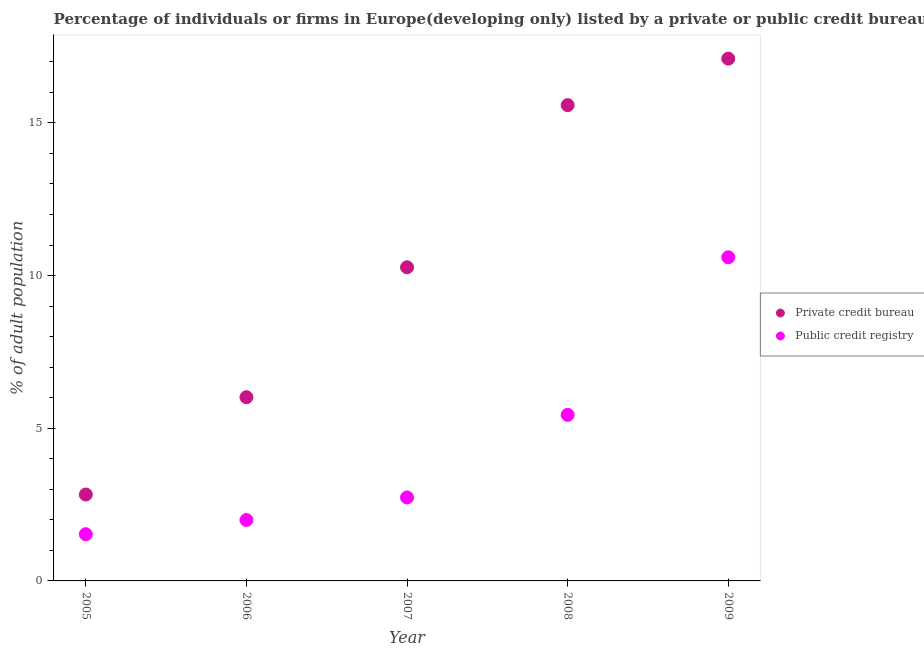How many different coloured dotlines are there?
Make the answer very short. 2. Is the number of dotlines equal to the number of legend labels?
Ensure brevity in your answer.  Yes. What is the percentage of firms listed by private credit bureau in 2006?
Offer a terse response. 6.02. Across all years, what is the maximum percentage of firms listed by private credit bureau?
Make the answer very short. 17.11. Across all years, what is the minimum percentage of firms listed by private credit bureau?
Give a very brief answer. 2.83. In which year was the percentage of firms listed by private credit bureau minimum?
Provide a short and direct response. 2005. What is the total percentage of firms listed by private credit bureau in the graph?
Give a very brief answer. 51.81. What is the difference between the percentage of firms listed by public credit bureau in 2005 and that in 2007?
Offer a terse response. -1.2. What is the difference between the percentage of firms listed by public credit bureau in 2006 and the percentage of firms listed by private credit bureau in 2008?
Your answer should be compact. -13.59. What is the average percentage of firms listed by private credit bureau per year?
Provide a short and direct response. 10.36. In the year 2005, what is the difference between the percentage of firms listed by public credit bureau and percentage of firms listed by private credit bureau?
Ensure brevity in your answer.  -1.3. In how many years, is the percentage of firms listed by private credit bureau greater than 8 %?
Keep it short and to the point. 3. What is the ratio of the percentage of firms listed by public credit bureau in 2007 to that in 2009?
Your response must be concise. 0.26. What is the difference between the highest and the second highest percentage of firms listed by public credit bureau?
Offer a very short reply. 5.16. What is the difference between the highest and the lowest percentage of firms listed by public credit bureau?
Give a very brief answer. 9.07. In how many years, is the percentage of firms listed by public credit bureau greater than the average percentage of firms listed by public credit bureau taken over all years?
Offer a very short reply. 2. Is the sum of the percentage of firms listed by public credit bureau in 2006 and 2009 greater than the maximum percentage of firms listed by private credit bureau across all years?
Provide a short and direct response. No. Is the percentage of firms listed by private credit bureau strictly greater than the percentage of firms listed by public credit bureau over the years?
Offer a very short reply. Yes. Is the percentage of firms listed by public credit bureau strictly less than the percentage of firms listed by private credit bureau over the years?
Offer a very short reply. Yes. How many dotlines are there?
Provide a short and direct response. 2. What is the difference between two consecutive major ticks on the Y-axis?
Offer a very short reply. 5. Are the values on the major ticks of Y-axis written in scientific E-notation?
Give a very brief answer. No. How many legend labels are there?
Offer a very short reply. 2. What is the title of the graph?
Ensure brevity in your answer.  Percentage of individuals or firms in Europe(developing only) listed by a private or public credit bureau. Does "Highest 10% of population" appear as one of the legend labels in the graph?
Give a very brief answer. No. What is the label or title of the Y-axis?
Ensure brevity in your answer.  % of adult population. What is the % of adult population of Private credit bureau in 2005?
Provide a short and direct response. 2.83. What is the % of adult population in Public credit registry in 2005?
Give a very brief answer. 1.53. What is the % of adult population of Private credit bureau in 2006?
Your answer should be very brief. 6.02. What is the % of adult population of Public credit registry in 2006?
Provide a short and direct response. 1.99. What is the % of adult population in Private credit bureau in 2007?
Ensure brevity in your answer.  10.27. What is the % of adult population of Public credit registry in 2007?
Your answer should be very brief. 2.73. What is the % of adult population in Private credit bureau in 2008?
Your answer should be very brief. 15.58. What is the % of adult population in Public credit registry in 2008?
Give a very brief answer. 5.44. What is the % of adult population in Private credit bureau in 2009?
Your answer should be very brief. 17.11. Across all years, what is the maximum % of adult population of Private credit bureau?
Give a very brief answer. 17.11. Across all years, what is the minimum % of adult population in Private credit bureau?
Keep it short and to the point. 2.83. Across all years, what is the minimum % of adult population of Public credit registry?
Your answer should be very brief. 1.53. What is the total % of adult population of Private credit bureau in the graph?
Your answer should be compact. 51.81. What is the total % of adult population of Public credit registry in the graph?
Ensure brevity in your answer.  22.3. What is the difference between the % of adult population of Private credit bureau in 2005 and that in 2006?
Your response must be concise. -3.19. What is the difference between the % of adult population of Public credit registry in 2005 and that in 2006?
Ensure brevity in your answer.  -0.47. What is the difference between the % of adult population in Private credit bureau in 2005 and that in 2007?
Offer a very short reply. -7.44. What is the difference between the % of adult population of Public credit registry in 2005 and that in 2007?
Your response must be concise. -1.2. What is the difference between the % of adult population of Private credit bureau in 2005 and that in 2008?
Keep it short and to the point. -12.75. What is the difference between the % of adult population in Public credit registry in 2005 and that in 2008?
Offer a very short reply. -3.91. What is the difference between the % of adult population of Private credit bureau in 2005 and that in 2009?
Give a very brief answer. -14.28. What is the difference between the % of adult population in Public credit registry in 2005 and that in 2009?
Give a very brief answer. -9.07. What is the difference between the % of adult population of Private credit bureau in 2006 and that in 2007?
Your answer should be very brief. -4.26. What is the difference between the % of adult population of Public credit registry in 2006 and that in 2007?
Ensure brevity in your answer.  -0.74. What is the difference between the % of adult population of Private credit bureau in 2006 and that in 2008?
Keep it short and to the point. -9.57. What is the difference between the % of adult population in Public credit registry in 2006 and that in 2008?
Your answer should be compact. -3.44. What is the difference between the % of adult population of Private credit bureau in 2006 and that in 2009?
Give a very brief answer. -11.09. What is the difference between the % of adult population of Public credit registry in 2006 and that in 2009?
Provide a succinct answer. -8.61. What is the difference between the % of adult population of Private credit bureau in 2007 and that in 2008?
Your response must be concise. -5.31. What is the difference between the % of adult population in Public credit registry in 2007 and that in 2008?
Provide a succinct answer. -2.71. What is the difference between the % of adult population in Private credit bureau in 2007 and that in 2009?
Your answer should be compact. -6.83. What is the difference between the % of adult population in Public credit registry in 2007 and that in 2009?
Provide a short and direct response. -7.87. What is the difference between the % of adult population in Private credit bureau in 2008 and that in 2009?
Keep it short and to the point. -1.52. What is the difference between the % of adult population of Public credit registry in 2008 and that in 2009?
Offer a very short reply. -5.16. What is the difference between the % of adult population of Private credit bureau in 2005 and the % of adult population of Public credit registry in 2006?
Your response must be concise. 0.83. What is the difference between the % of adult population of Private credit bureau in 2005 and the % of adult population of Public credit registry in 2007?
Keep it short and to the point. 0.1. What is the difference between the % of adult population in Private credit bureau in 2005 and the % of adult population in Public credit registry in 2008?
Offer a very short reply. -2.61. What is the difference between the % of adult population of Private credit bureau in 2005 and the % of adult population of Public credit registry in 2009?
Provide a short and direct response. -7.77. What is the difference between the % of adult population of Private credit bureau in 2006 and the % of adult population of Public credit registry in 2007?
Offer a very short reply. 3.28. What is the difference between the % of adult population in Private credit bureau in 2006 and the % of adult population in Public credit registry in 2008?
Provide a short and direct response. 0.58. What is the difference between the % of adult population in Private credit bureau in 2006 and the % of adult population in Public credit registry in 2009?
Your response must be concise. -4.58. What is the difference between the % of adult population of Private credit bureau in 2007 and the % of adult population of Public credit registry in 2008?
Ensure brevity in your answer.  4.83. What is the difference between the % of adult population in Private credit bureau in 2007 and the % of adult population in Public credit registry in 2009?
Give a very brief answer. -0.33. What is the difference between the % of adult population in Private credit bureau in 2008 and the % of adult population in Public credit registry in 2009?
Keep it short and to the point. 4.98. What is the average % of adult population in Private credit bureau per year?
Make the answer very short. 10.36. What is the average % of adult population in Public credit registry per year?
Your response must be concise. 4.46. In the year 2005, what is the difference between the % of adult population in Private credit bureau and % of adult population in Public credit registry?
Make the answer very short. 1.3. In the year 2006, what is the difference between the % of adult population in Private credit bureau and % of adult population in Public credit registry?
Give a very brief answer. 4.02. In the year 2007, what is the difference between the % of adult population of Private credit bureau and % of adult population of Public credit registry?
Your answer should be compact. 7.54. In the year 2008, what is the difference between the % of adult population of Private credit bureau and % of adult population of Public credit registry?
Offer a very short reply. 10.14. In the year 2009, what is the difference between the % of adult population in Private credit bureau and % of adult population in Public credit registry?
Your response must be concise. 6.51. What is the ratio of the % of adult population of Private credit bureau in 2005 to that in 2006?
Keep it short and to the point. 0.47. What is the ratio of the % of adult population of Public credit registry in 2005 to that in 2006?
Your response must be concise. 0.77. What is the ratio of the % of adult population of Private credit bureau in 2005 to that in 2007?
Provide a short and direct response. 0.28. What is the ratio of the % of adult population in Public credit registry in 2005 to that in 2007?
Your answer should be very brief. 0.56. What is the ratio of the % of adult population of Private credit bureau in 2005 to that in 2008?
Provide a succinct answer. 0.18. What is the ratio of the % of adult population in Public credit registry in 2005 to that in 2008?
Your answer should be compact. 0.28. What is the ratio of the % of adult population in Private credit bureau in 2005 to that in 2009?
Provide a succinct answer. 0.17. What is the ratio of the % of adult population in Public credit registry in 2005 to that in 2009?
Provide a short and direct response. 0.14. What is the ratio of the % of adult population of Private credit bureau in 2006 to that in 2007?
Keep it short and to the point. 0.59. What is the ratio of the % of adult population of Public credit registry in 2006 to that in 2007?
Your answer should be very brief. 0.73. What is the ratio of the % of adult population in Private credit bureau in 2006 to that in 2008?
Ensure brevity in your answer.  0.39. What is the ratio of the % of adult population of Public credit registry in 2006 to that in 2008?
Offer a very short reply. 0.37. What is the ratio of the % of adult population in Private credit bureau in 2006 to that in 2009?
Keep it short and to the point. 0.35. What is the ratio of the % of adult population of Public credit registry in 2006 to that in 2009?
Provide a succinct answer. 0.19. What is the ratio of the % of adult population in Private credit bureau in 2007 to that in 2008?
Your response must be concise. 0.66. What is the ratio of the % of adult population of Public credit registry in 2007 to that in 2008?
Provide a succinct answer. 0.5. What is the ratio of the % of adult population of Private credit bureau in 2007 to that in 2009?
Your answer should be very brief. 0.6. What is the ratio of the % of adult population in Public credit registry in 2007 to that in 2009?
Give a very brief answer. 0.26. What is the ratio of the % of adult population in Private credit bureau in 2008 to that in 2009?
Offer a terse response. 0.91. What is the ratio of the % of adult population in Public credit registry in 2008 to that in 2009?
Your response must be concise. 0.51. What is the difference between the highest and the second highest % of adult population of Private credit bureau?
Your answer should be compact. 1.52. What is the difference between the highest and the second highest % of adult population of Public credit registry?
Your answer should be very brief. 5.16. What is the difference between the highest and the lowest % of adult population in Private credit bureau?
Offer a very short reply. 14.28. What is the difference between the highest and the lowest % of adult population of Public credit registry?
Offer a terse response. 9.07. 